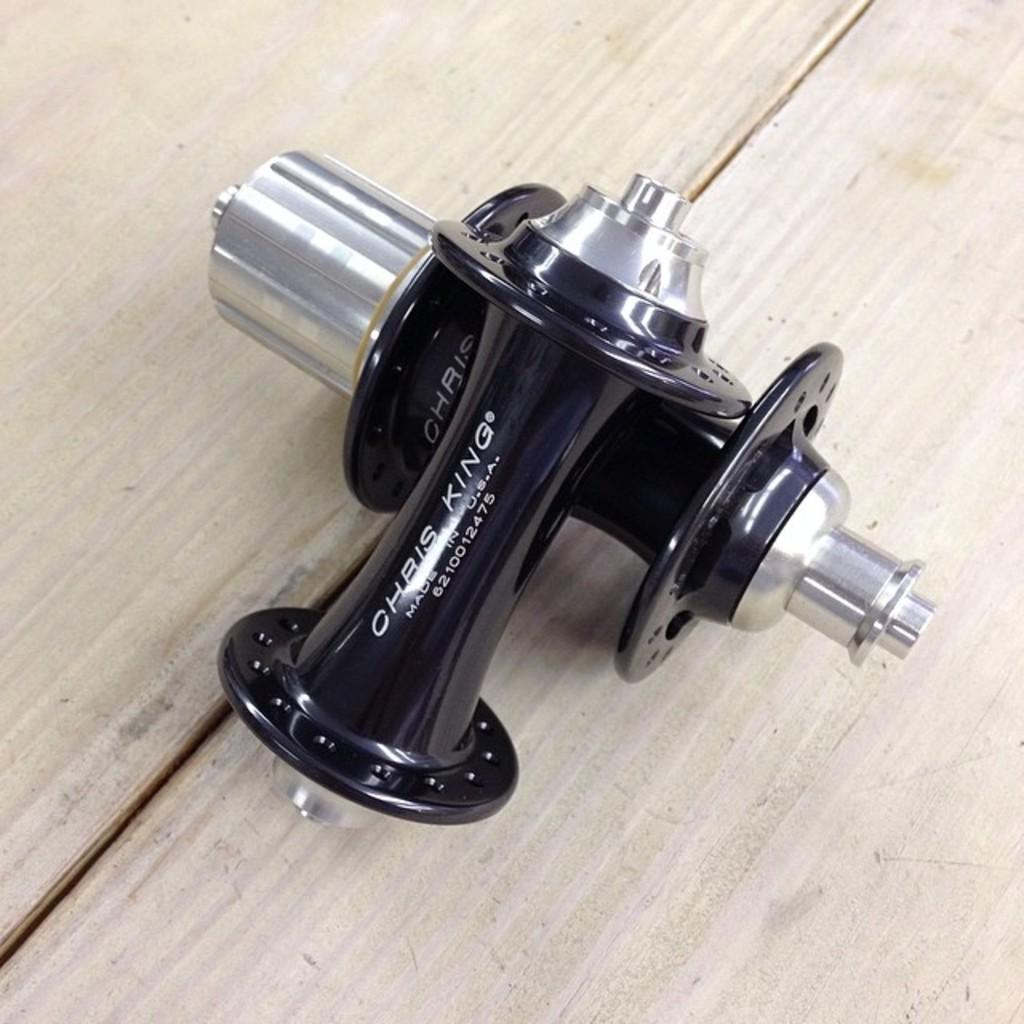What is the color of the object in the image? The object in the image has a black and silver color. What is the object placed on in the image? The object is on a cream color surface. What type of fang can be seen in the image? There is no fang present in the image. What month is depicted in the image? The image does not depict a month; it features a black and silver color object on a cream color surface. 